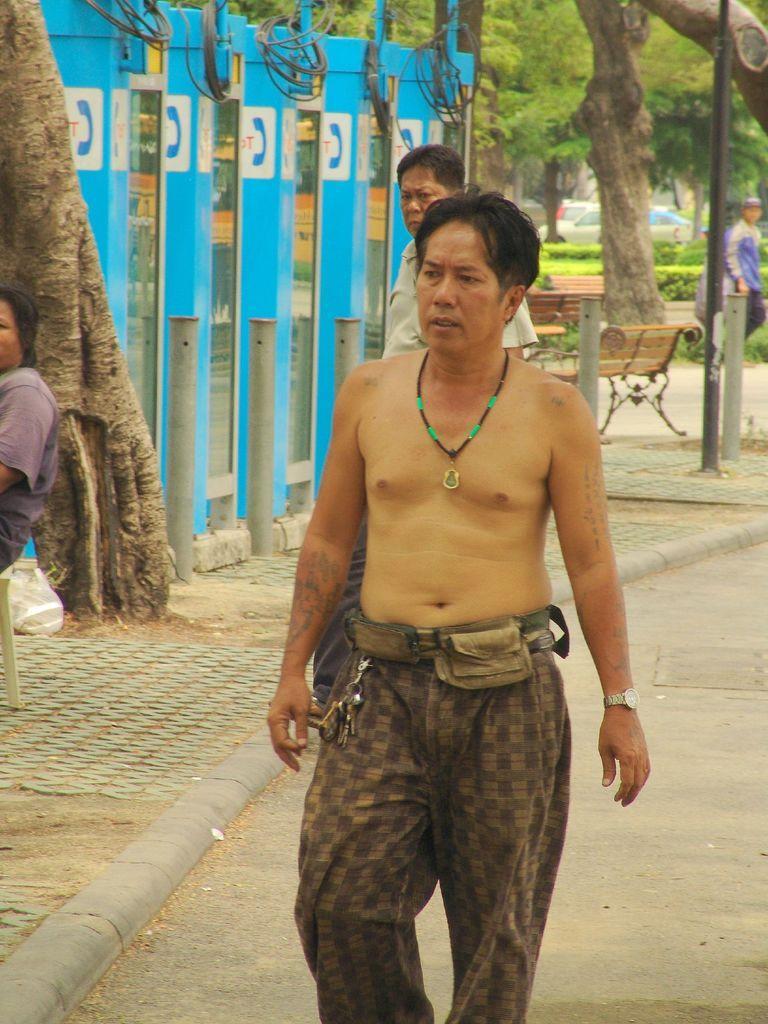How would you summarize this image in a sentence or two? In the image there is a man walking on the path and beside him there is a footpath, there is a tree trunk on the footpath and behind that there are telephone booths, behind the telephone booths it looks like there is a park. 